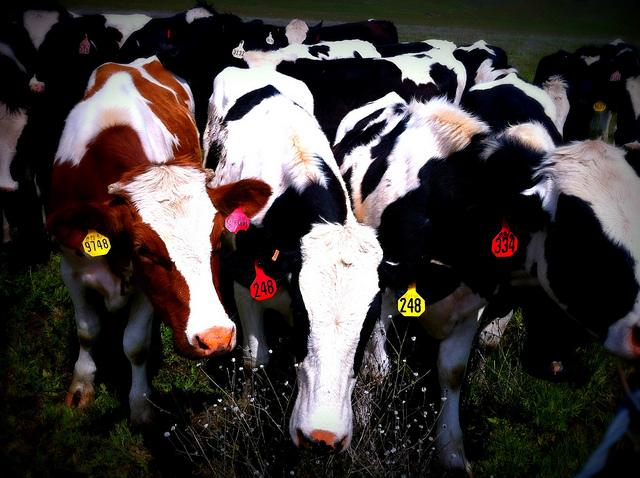What is the largest number on the yellow tags? 9748 